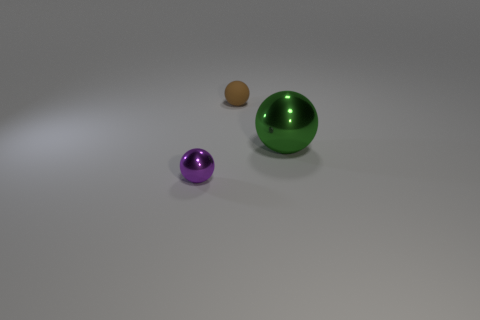Is there any other thing that is the same material as the tiny brown ball?
Offer a terse response. No. Is there anything else that is the same color as the tiny matte ball?
Your answer should be very brief. No. Are there more green metallic things to the right of the small metallic object than tiny gray matte things?
Provide a succinct answer. Yes. Is the green ball the same size as the matte sphere?
Offer a terse response. No. There is another large object that is the same shape as the rubber object; what material is it?
Provide a succinct answer. Metal. How many cyan things are matte objects or shiny balls?
Keep it short and to the point. 0. What is the tiny ball to the left of the tiny brown thing made of?
Your answer should be very brief. Metal. Is the number of large gray shiny cubes greater than the number of purple spheres?
Make the answer very short. No. There is a object to the right of the matte thing; is it the same shape as the purple thing?
Offer a terse response. Yes. How many balls are left of the big green sphere and in front of the matte thing?
Provide a short and direct response. 1. 